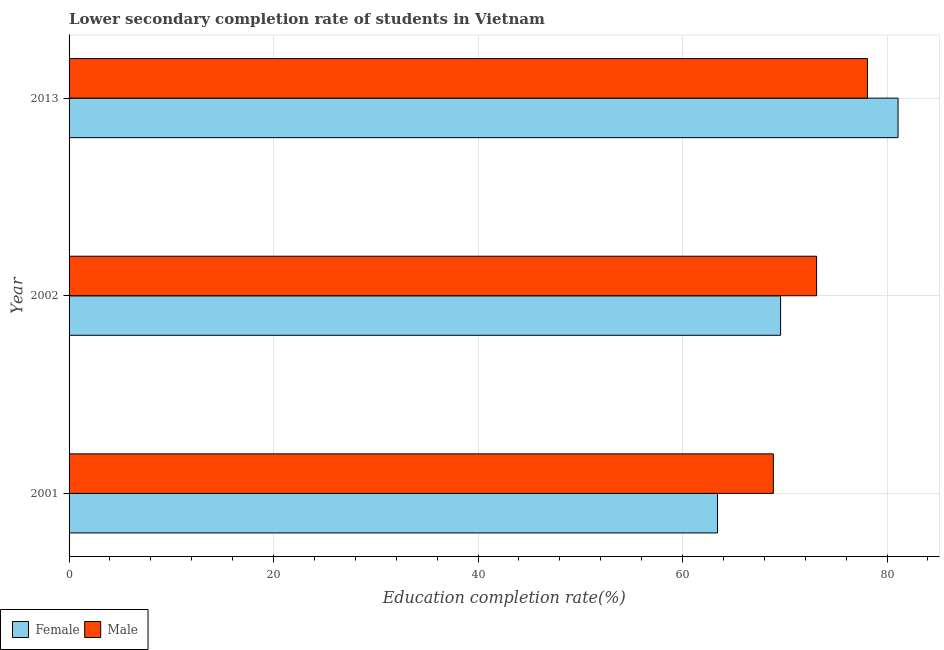How many groups of bars are there?
Ensure brevity in your answer.  3. Are the number of bars per tick equal to the number of legend labels?
Offer a terse response. Yes. How many bars are there on the 2nd tick from the top?
Your response must be concise. 2. What is the education completion rate of female students in 2013?
Ensure brevity in your answer.  81.08. Across all years, what is the maximum education completion rate of female students?
Make the answer very short. 81.08. Across all years, what is the minimum education completion rate of female students?
Your answer should be very brief. 63.42. In which year was the education completion rate of male students maximum?
Offer a very short reply. 2013. In which year was the education completion rate of male students minimum?
Your answer should be compact. 2001. What is the total education completion rate of female students in the graph?
Your answer should be very brief. 214.09. What is the difference between the education completion rate of male students in 2002 and that in 2013?
Your response must be concise. -4.97. What is the difference between the education completion rate of male students in 2013 and the education completion rate of female students in 2002?
Provide a succinct answer. 8.49. What is the average education completion rate of male students per year?
Offer a very short reply. 73.36. In the year 2002, what is the difference between the education completion rate of female students and education completion rate of male students?
Make the answer very short. -3.52. In how many years, is the education completion rate of male students greater than 24 %?
Ensure brevity in your answer.  3. What is the ratio of the education completion rate of male students in 2001 to that in 2002?
Provide a short and direct response. 0.94. What is the difference between the highest and the second highest education completion rate of female students?
Keep it short and to the point. 11.49. What is the difference between the highest and the lowest education completion rate of female students?
Provide a succinct answer. 17.66. Are all the bars in the graph horizontal?
Provide a succinct answer. Yes. How many years are there in the graph?
Provide a short and direct response. 3. What is the difference between two consecutive major ticks on the X-axis?
Provide a succinct answer. 20. Where does the legend appear in the graph?
Provide a succinct answer. Bottom left. How are the legend labels stacked?
Your response must be concise. Horizontal. What is the title of the graph?
Provide a succinct answer. Lower secondary completion rate of students in Vietnam. Does "Gasoline" appear as one of the legend labels in the graph?
Your response must be concise. No. What is the label or title of the X-axis?
Your answer should be compact. Education completion rate(%). What is the label or title of the Y-axis?
Offer a terse response. Year. What is the Education completion rate(%) of Female in 2001?
Your answer should be compact. 63.42. What is the Education completion rate(%) of Male in 2001?
Ensure brevity in your answer.  68.88. What is the Education completion rate(%) of Female in 2002?
Make the answer very short. 69.59. What is the Education completion rate(%) of Male in 2002?
Make the answer very short. 73.11. What is the Education completion rate(%) of Female in 2013?
Provide a short and direct response. 81.08. What is the Education completion rate(%) of Male in 2013?
Your answer should be compact. 78.08. Across all years, what is the maximum Education completion rate(%) in Female?
Provide a succinct answer. 81.08. Across all years, what is the maximum Education completion rate(%) in Male?
Offer a very short reply. 78.08. Across all years, what is the minimum Education completion rate(%) in Female?
Provide a short and direct response. 63.42. Across all years, what is the minimum Education completion rate(%) in Male?
Your answer should be very brief. 68.88. What is the total Education completion rate(%) in Female in the graph?
Keep it short and to the point. 214.09. What is the total Education completion rate(%) in Male in the graph?
Your answer should be very brief. 220.07. What is the difference between the Education completion rate(%) of Female in 2001 and that in 2002?
Provide a short and direct response. -6.17. What is the difference between the Education completion rate(%) of Male in 2001 and that in 2002?
Offer a terse response. -4.23. What is the difference between the Education completion rate(%) of Female in 2001 and that in 2013?
Make the answer very short. -17.66. What is the difference between the Education completion rate(%) of Male in 2001 and that in 2013?
Your answer should be compact. -9.21. What is the difference between the Education completion rate(%) of Female in 2002 and that in 2013?
Your response must be concise. -11.49. What is the difference between the Education completion rate(%) of Male in 2002 and that in 2013?
Keep it short and to the point. -4.97. What is the difference between the Education completion rate(%) in Female in 2001 and the Education completion rate(%) in Male in 2002?
Offer a terse response. -9.69. What is the difference between the Education completion rate(%) in Female in 2001 and the Education completion rate(%) in Male in 2013?
Make the answer very short. -14.66. What is the difference between the Education completion rate(%) of Female in 2002 and the Education completion rate(%) of Male in 2013?
Keep it short and to the point. -8.49. What is the average Education completion rate(%) of Female per year?
Offer a terse response. 71.36. What is the average Education completion rate(%) in Male per year?
Provide a short and direct response. 73.36. In the year 2001, what is the difference between the Education completion rate(%) of Female and Education completion rate(%) of Male?
Make the answer very short. -5.46. In the year 2002, what is the difference between the Education completion rate(%) of Female and Education completion rate(%) of Male?
Your answer should be very brief. -3.52. In the year 2013, what is the difference between the Education completion rate(%) in Female and Education completion rate(%) in Male?
Offer a very short reply. 2.99. What is the ratio of the Education completion rate(%) in Female in 2001 to that in 2002?
Provide a short and direct response. 0.91. What is the ratio of the Education completion rate(%) in Male in 2001 to that in 2002?
Your answer should be compact. 0.94. What is the ratio of the Education completion rate(%) of Female in 2001 to that in 2013?
Ensure brevity in your answer.  0.78. What is the ratio of the Education completion rate(%) in Male in 2001 to that in 2013?
Offer a terse response. 0.88. What is the ratio of the Education completion rate(%) of Female in 2002 to that in 2013?
Your answer should be very brief. 0.86. What is the ratio of the Education completion rate(%) in Male in 2002 to that in 2013?
Your response must be concise. 0.94. What is the difference between the highest and the second highest Education completion rate(%) of Female?
Provide a succinct answer. 11.49. What is the difference between the highest and the second highest Education completion rate(%) of Male?
Keep it short and to the point. 4.97. What is the difference between the highest and the lowest Education completion rate(%) of Female?
Make the answer very short. 17.66. What is the difference between the highest and the lowest Education completion rate(%) in Male?
Ensure brevity in your answer.  9.21. 